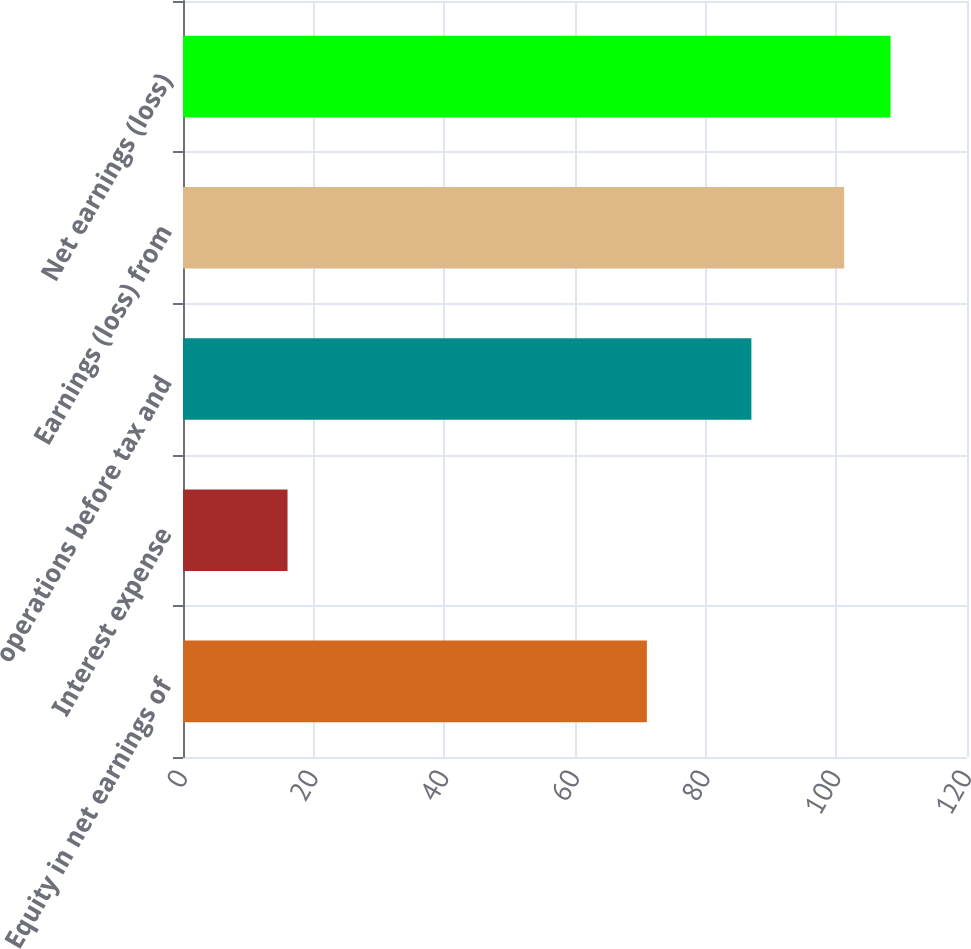<chart> <loc_0><loc_0><loc_500><loc_500><bar_chart><fcel>Equity in net earnings of<fcel>Interest expense<fcel>operations before tax and<fcel>Earnings (loss) from<fcel>Net earnings (loss)<nl><fcel>71<fcel>16<fcel>87<fcel>101.2<fcel>108.3<nl></chart> 